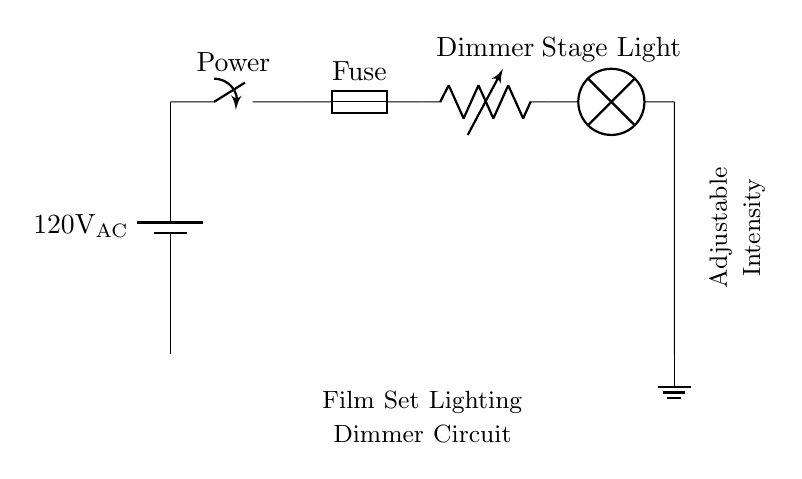What is the voltage rating of the power source? The circuit diagram indicates that the power source is labeled as 120V AC, which specifies the voltage rating for this circuit.
Answer: 120V AC What component controls the lighting intensity? In the circuit, the component responsible for controlling the lighting intensity is the variable resistor, commonly known as a dimmer. This is because it allows adjustments to be made to the amount of current flowing to the light.
Answer: Dimmer How many main components are visible in the circuit? The circuit diagram includes four main components: the battery (power source), switch, fuse, and dimmer, along with the stage light. Counting these gives a total of five components.
Answer: Five What is the purpose of the fuse in this circuit? The fuse is included in circuits to protect against overloads or short circuits. It acts as a safety device that interrupts the flow of electricity when the current exceeds a certain level, preventing damage to the components.
Answer: Safety protection What does the label "Adjustable Intensity" signify? The label "Adjustable Intensity" indicates that the circuit incorporates a mechanism (the variable resistor/dimmer) that allows users to modify the brightness of the connected stage lights, making them suitable for different filming scenarios.
Answer: Brightness control What type of circuit is illustrated in the diagram? The circuit diagram represents a dimmer circuit, which is specifically designed for adjusting the lighting intensity in a film set environment. Its components are tailored to manage lighting efficiently for various filming needs.
Answer: Dimmer circuit What role does the switch play in this circuit? The switch in the circuit serves to control the flow of electricity. It can open or close the circuit, thus allowing the lights to be turned on or off as needed on the film set.
Answer: Control flow 